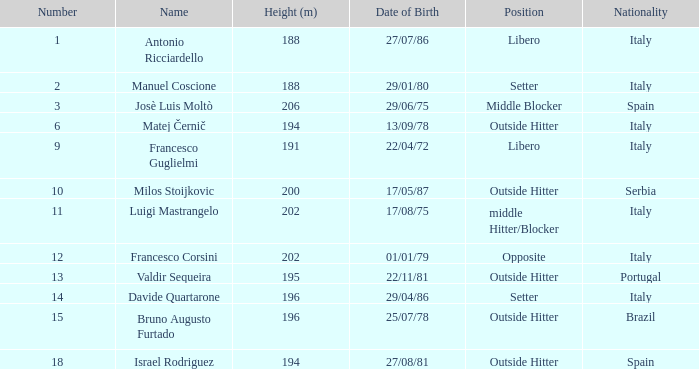What is the height for someone born on 17/08/75? 202.0. 